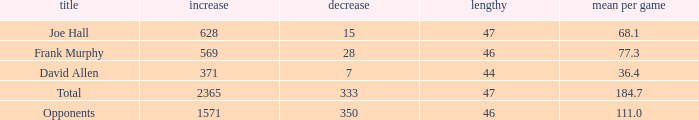Could you help me parse every detail presented in this table? {'header': ['title', 'increase', 'decrease', 'lengthy', 'mean per game'], 'rows': [['Joe Hall', '628', '15', '47', '68.1'], ['Frank Murphy', '569', '28', '46', '77.3'], ['David Allen', '371', '7', '44', '36.4'], ['Total', '2365', '333', '47', '184.7'], ['Opponents', '1571', '350', '46', '111.0']]} How much Loss has a Gain smaller than 1571, and a Long smaller than 47, and an Avg/G of 36.4? 1.0. 